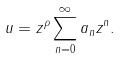Convert formula to latex. <formula><loc_0><loc_0><loc_500><loc_500>u = z ^ { \rho } \sum _ { n = 0 } ^ { \infty } a _ { n } z ^ { n } .</formula> 